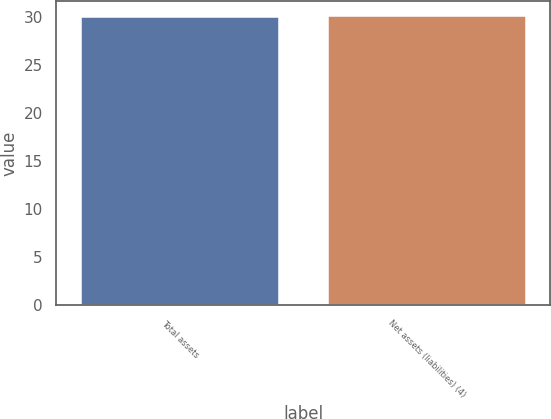Convert chart. <chart><loc_0><loc_0><loc_500><loc_500><bar_chart><fcel>Total assets<fcel>Net assets (liabilities) (4)<nl><fcel>30<fcel>30.1<nl></chart> 